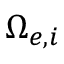Convert formula to latex. <formula><loc_0><loc_0><loc_500><loc_500>\Omega _ { e , i }</formula> 